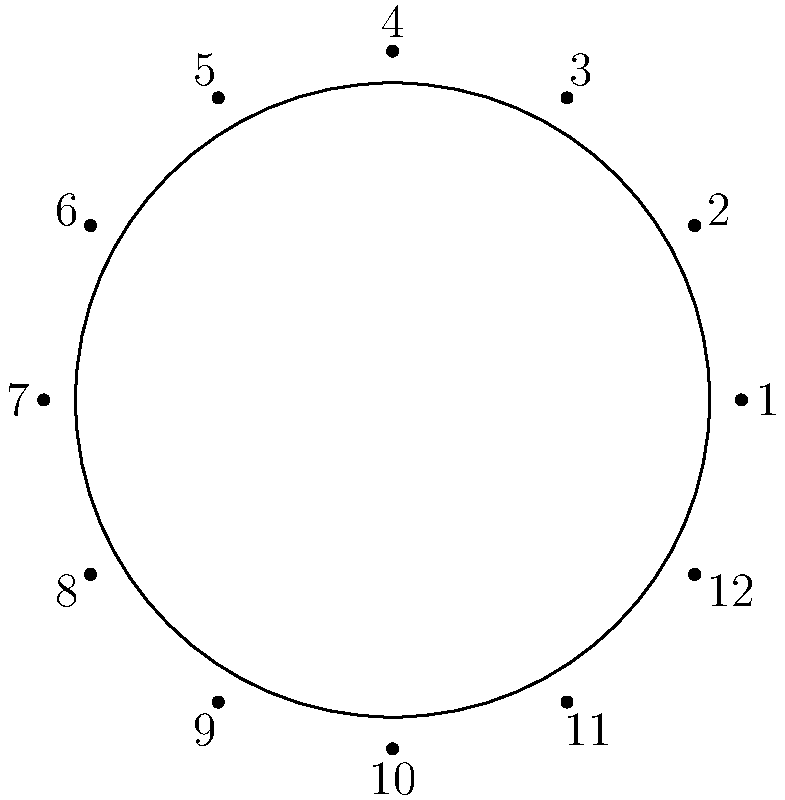In a circular arrangement of 12 piano keys, how many different ways can you play a three-note chord if the order of playing the notes matters and repetition is not allowed? Let's approach this step-by-step:

1) We have 12 keys in total, arranged in a circle.

2) We need to choose 3 keys out of these 12.

3) The order matters, which means (1,2,3) is considered different from (2,1,3).

4) Repetition is not allowed, meaning we can't use the same key more than once in a chord.

5) This scenario is a permutation problem. We are selecting 3 keys out of 12, where order matters and repetition is not allowed.

6) The formula for this type of permutation is:

   $P(n,r) = \frac{n!}{(n-r)!}$

   Where $n$ is the total number of items (12 in this case) and $r$ is the number of items being chosen (3 in this case).

7) Plugging in our numbers:

   $P(12,3) = \frac{12!}{(12-3)!} = \frac{12!}{9!}$

8) Expanding this:

   $\frac{12 * 11 * 10 * 9!}{9!}$

9) The 9! cancels out in the numerator and denominator:

   $12 * 11 * 10 = 1320$

Therefore, there are 1320 different ways to play a three-note chord under these conditions.
Answer: 1320 